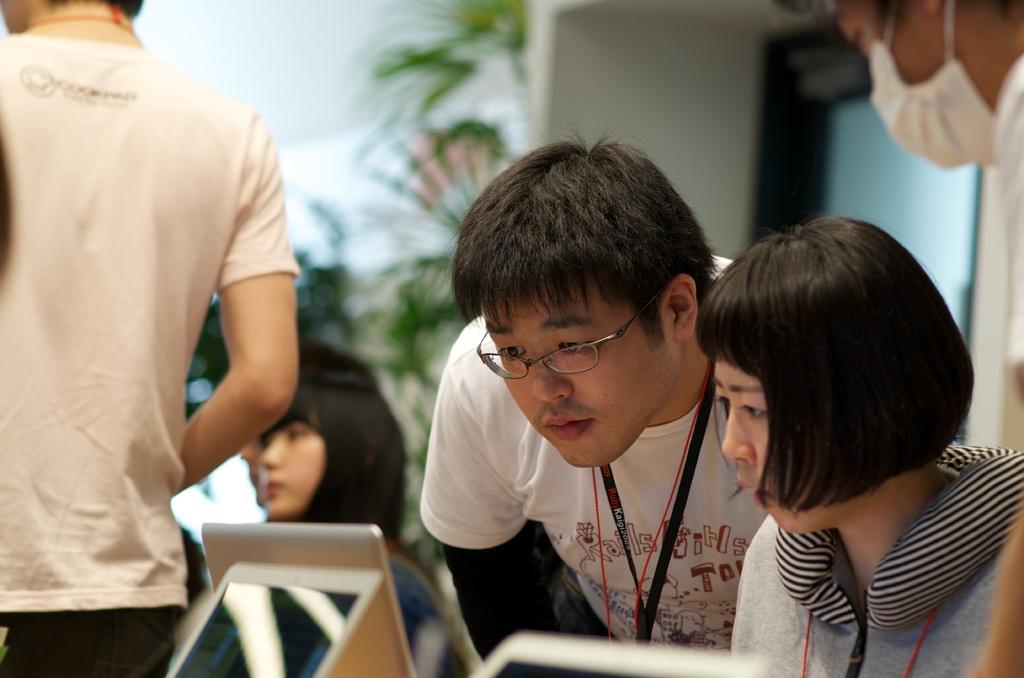Describe this image in one or two sentences. In this image there are group of people in the foreground there is one man who is wearing spectacles and tag, and he is looking in to laptops. At the bottom there are some laptops, and in the background there are some plants, wall and windows. 